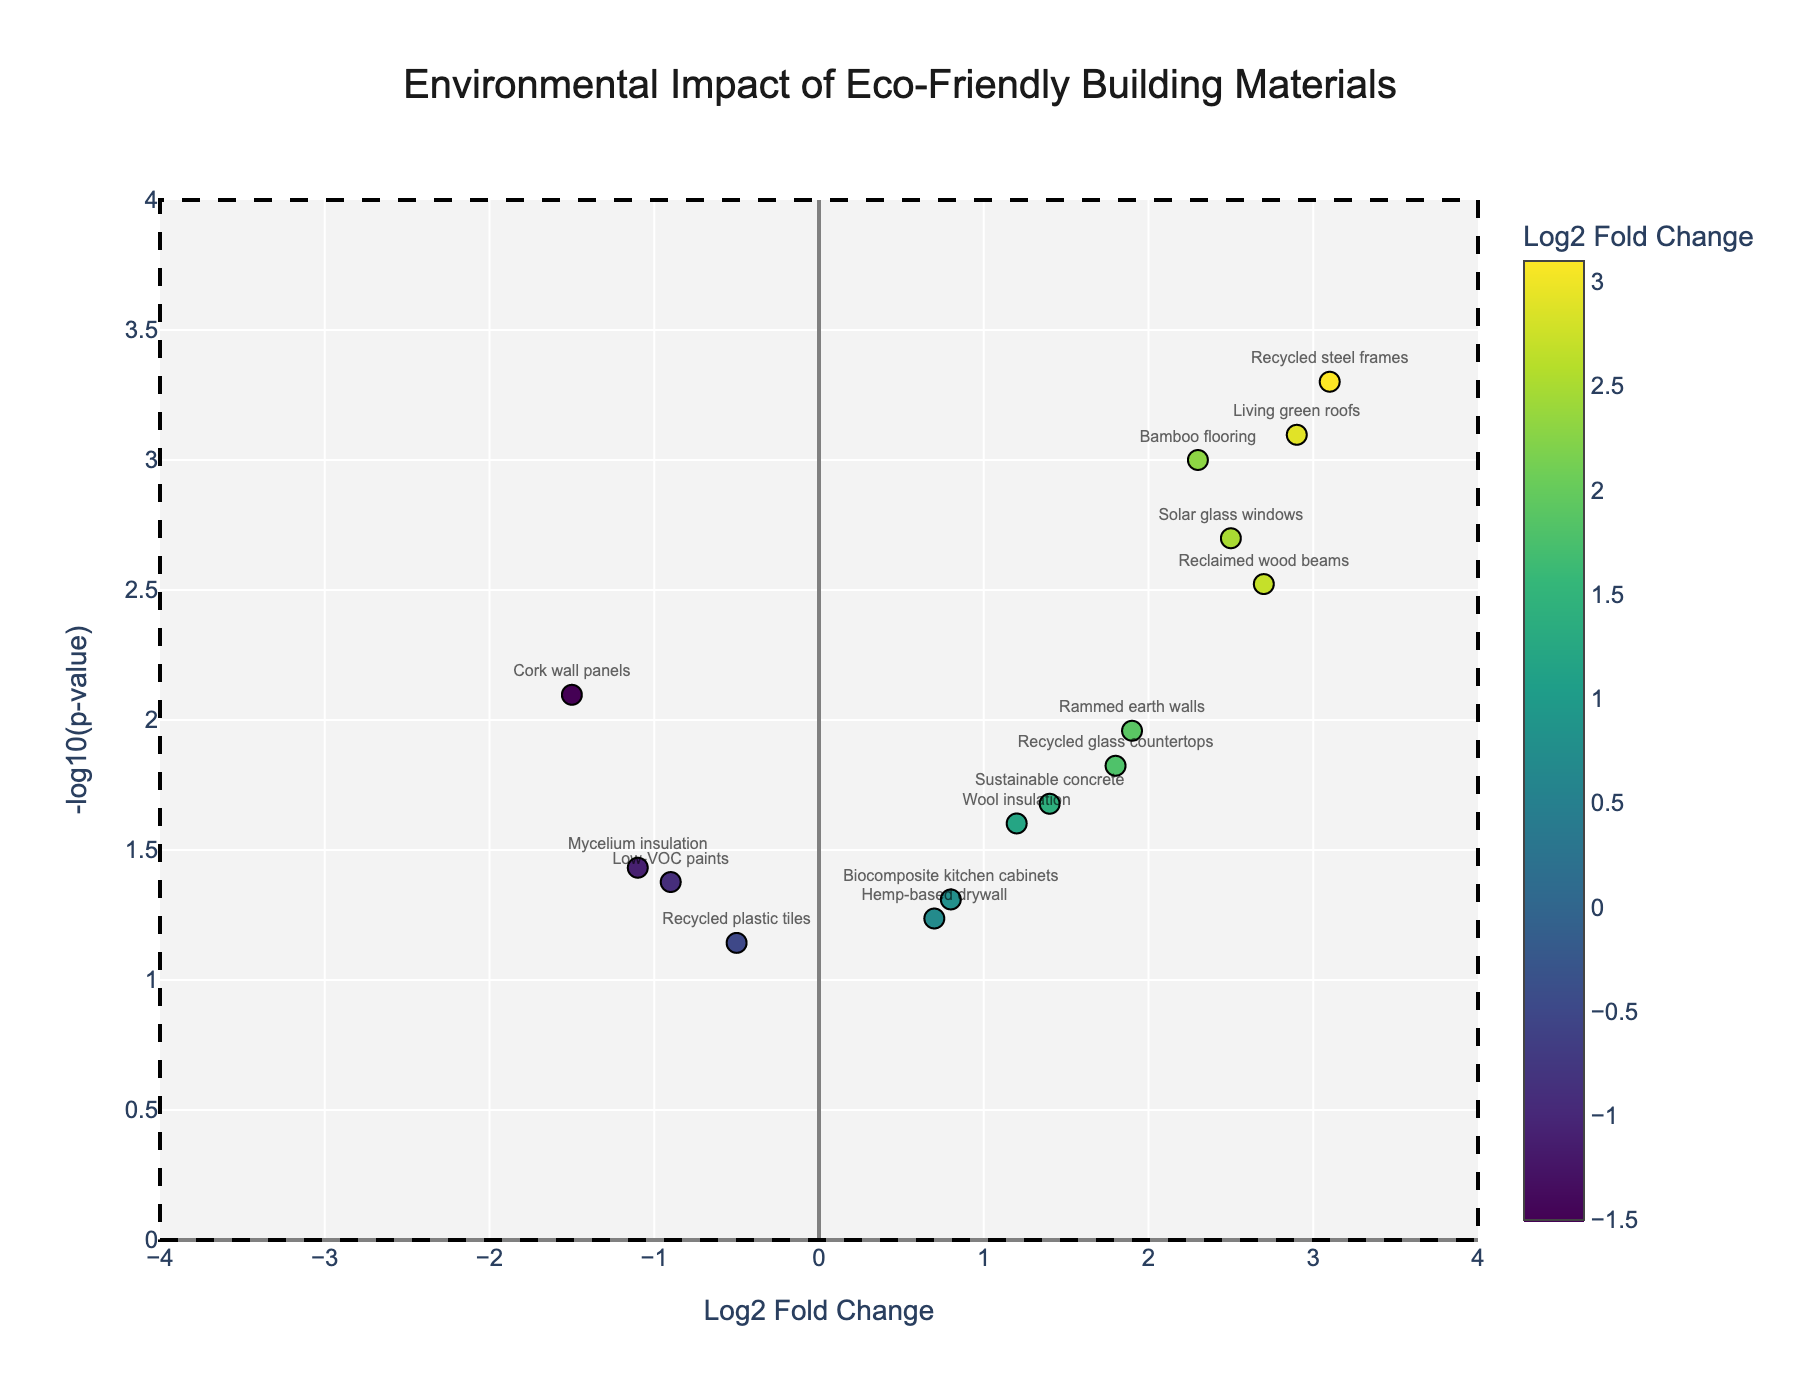What's the title of the figure? The title is given at the top of the figure and is usually the main descriptor of what the plot represents.
Answer: Environmental Impact of Eco-Friendly Building Materials What does the y-axis represent? The y-axis represents the negative log base 10 of the p-value; it indicates the significance of the environmental impact.
Answer: -log10(p-value) Which material shows the highest Log2 Fold Change? By identifying the highest point on the x-axis, we find the material with the highest log2 fold change. In this case, it is recycled steel frames.
Answer: Recycled steel frames Which materials have a Log2 Fold Change greater than 2? Review the x-axis for materials that are positioned beyond the value of 2 to the right. These materials are bamboo flooring, reclaimed wood beams, solar glass windows, and living green roofs.
Answer: Bamboo flooring, reclaimed wood beams, solar glass windows, living green roofs Which material has the lowest p-value? The lowest p-value will be at the highest point on the y-axis because the p-value is transformed as -log10(p-value). Recycled steel frames have the highest y-axis position.
Answer: Recycled steel frames How many materials have a negative Log2 Fold Change? Count the number of data points positioned to the left of zero on the x-axis. These materials are cork wall panels, low-VOC paints, mycelium insulation, and recycled plastic tiles.
Answer: Four materials Which material has the least statistically significant result? The least significant result will have the lowest position on the y-axis, indicated by the smallest -log10(p-value). Recycled plastic tiles are the lowest on the y-axis.
Answer: Recycled plastic tiles What is the -log10(p-value) threshold for statistical significance in this plot? The threshold for statistical significance is represented by a horizontal red dashed line. This line intersects the y-axis at a -log10(p-value) value of -log10(0.05).
Answer: ~1.301 Which material has a -log10(p-value) close to 1.5 and a positive Log2 Fold Change? Identify the data point near the y-value of 1.5 and on the right side of the x-axis. The closest material is wool insulation.
Answer: Wool insulation Compare the significance of the environmental impact between solar glass windows and bamboo flooring. Which one is more significant? Compare the y-axis values of both data points. Solar glass windows are positioned higher on the y-axis, indicating a lower p-value and therefore more significance than bamboo flooring.
Answer: Solar glass windows 